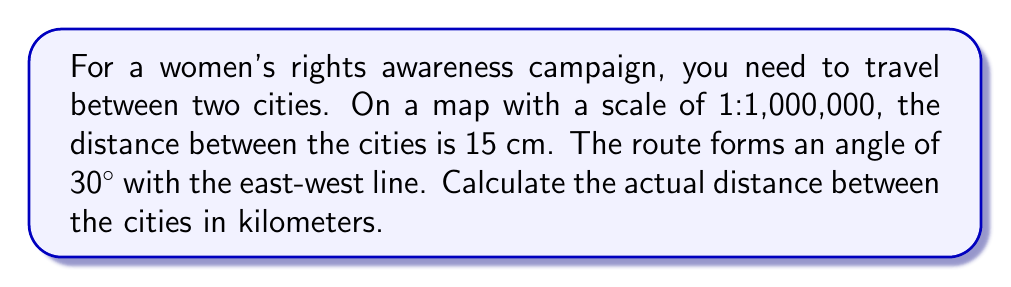What is the answer to this math problem? Let's approach this step-by-step:

1) First, we need to understand what the map scale means:
   1:1,000,000 means that 1 cm on the map represents 1,000,000 cm in real life.

2) Convert the map distance to real-world distance:
   15 cm * 1,000,000 = 15,000,000 cm = 150 km

3) Now, we need to consider the angle. The question states that the route forms a 30° angle with the east-west line. This means we can use trigonometry to find the actual distance.

4) We can visualize this as a right-angled triangle, where:
   - The hypotenuse is the actual distance we're looking for
   - The adjacent side is the east-west distance of 150 km
   - The angle between these is 30°

5) We can use the cosine function to find the hypotenuse (actual distance):

   $$\cos 30° = \frac{\text{adjacent}}{\text{hypotenuse}}$$

   $$\cos 30° = \frac{150}{\text{hypotenuse}}$$

6) Rearranging this equation:

   $$\text{hypotenuse} = \frac{150}{\cos 30°}$$

7) We know that $\cos 30° = \frac{\sqrt{3}}{2}$, so:

   $$\text{hypotenuse} = \frac{150}{\frac{\sqrt{3}}{2}} = 150 * \frac{2}{\sqrt{3}} = \frac{300}{\sqrt{3}}$$

8) Simplifying:

   $$\frac{300}{\sqrt{3}} = 100\sqrt{3} \approx 173.21 \text{ km}$$
Answer: $173.21 \text{ km}$ 